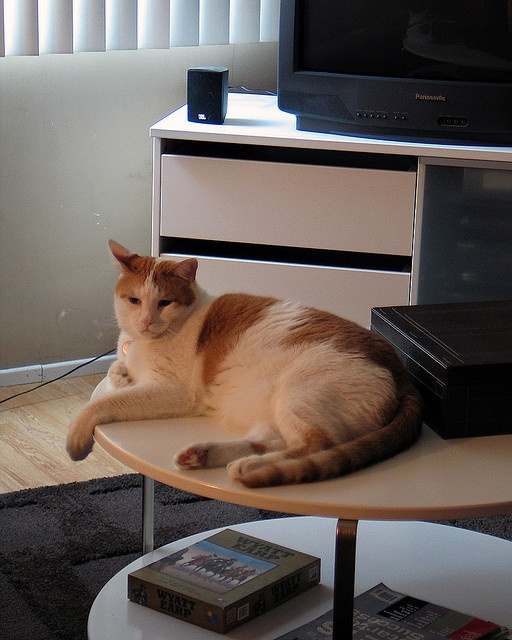Describe the objects in this image and their specific colors. I can see cat in gray, tan, maroon, and black tones, tv in gray, black, navy, and darkblue tones, book in gray and black tones, and book in gray and black tones in this image. 